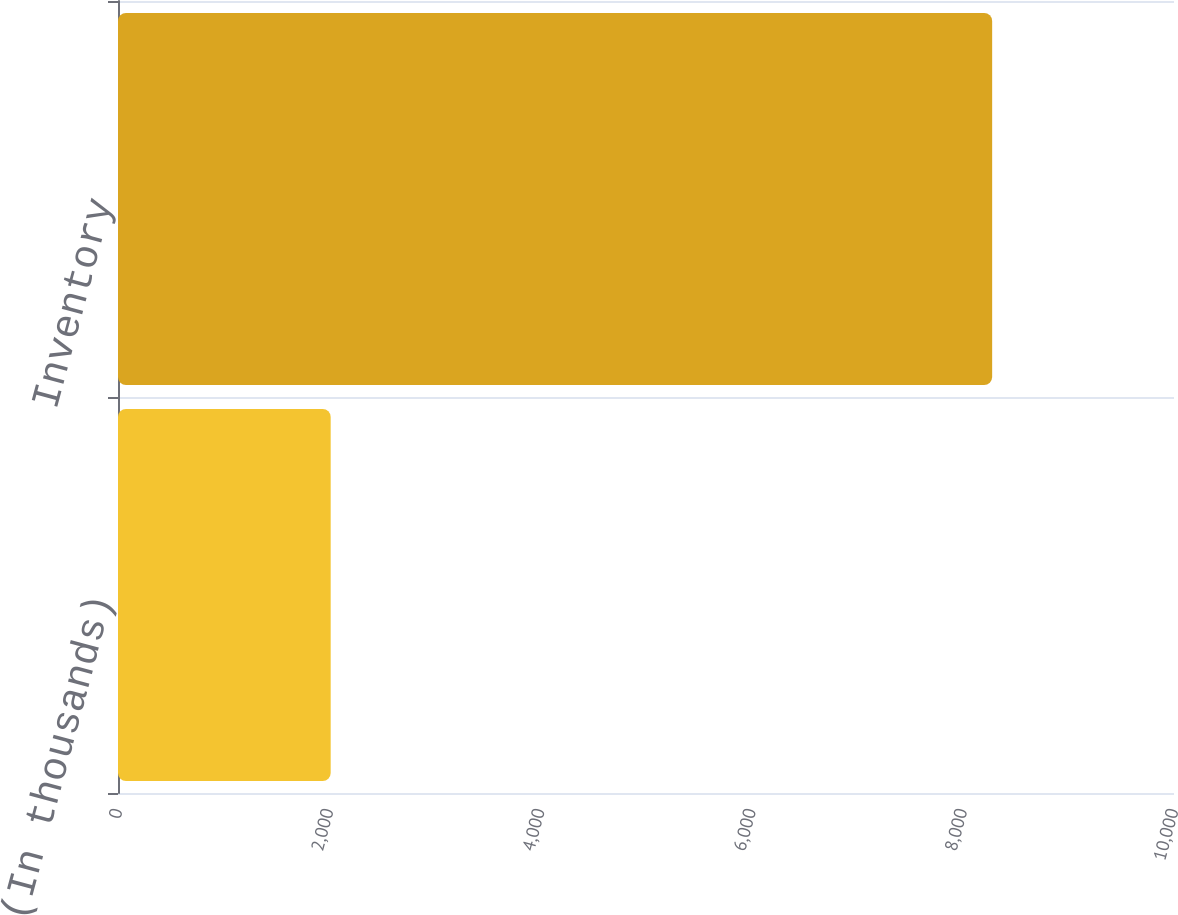<chart> <loc_0><loc_0><loc_500><loc_500><bar_chart><fcel>(In thousands)<fcel>Inventory<nl><fcel>2014<fcel>8278<nl></chart> 